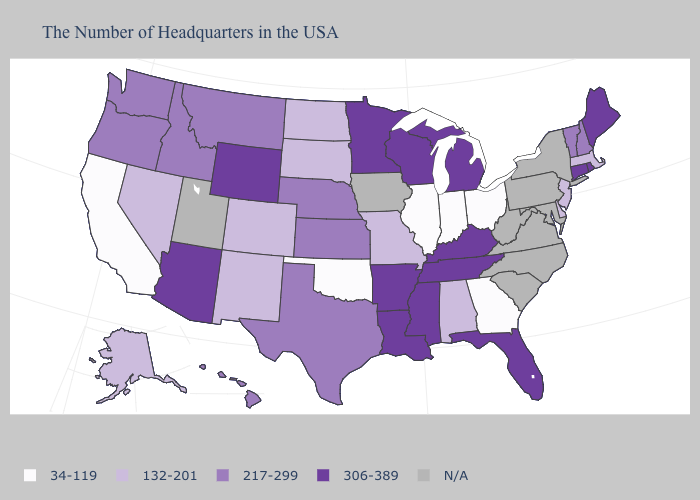What is the value of California?
Answer briefly. 34-119. Name the states that have a value in the range 217-299?
Give a very brief answer. New Hampshire, Vermont, Kansas, Nebraska, Texas, Montana, Idaho, Washington, Oregon, Hawaii. Does the first symbol in the legend represent the smallest category?
Write a very short answer. Yes. What is the lowest value in the West?
Answer briefly. 34-119. How many symbols are there in the legend?
Keep it brief. 5. Name the states that have a value in the range 306-389?
Give a very brief answer. Maine, Rhode Island, Connecticut, Florida, Michigan, Kentucky, Tennessee, Wisconsin, Mississippi, Louisiana, Arkansas, Minnesota, Wyoming, Arizona. What is the value of Indiana?
Answer briefly. 34-119. Name the states that have a value in the range 132-201?
Short answer required. Massachusetts, New Jersey, Delaware, Alabama, Missouri, South Dakota, North Dakota, Colorado, New Mexico, Nevada, Alaska. Does the map have missing data?
Concise answer only. Yes. What is the value of Georgia?
Quick response, please. 34-119. What is the highest value in the South ?
Concise answer only. 306-389. What is the value of Illinois?
Write a very short answer. 34-119. What is the value of Maine?
Concise answer only. 306-389. What is the value of Minnesota?
Be succinct. 306-389. What is the highest value in states that border California?
Give a very brief answer. 306-389. 